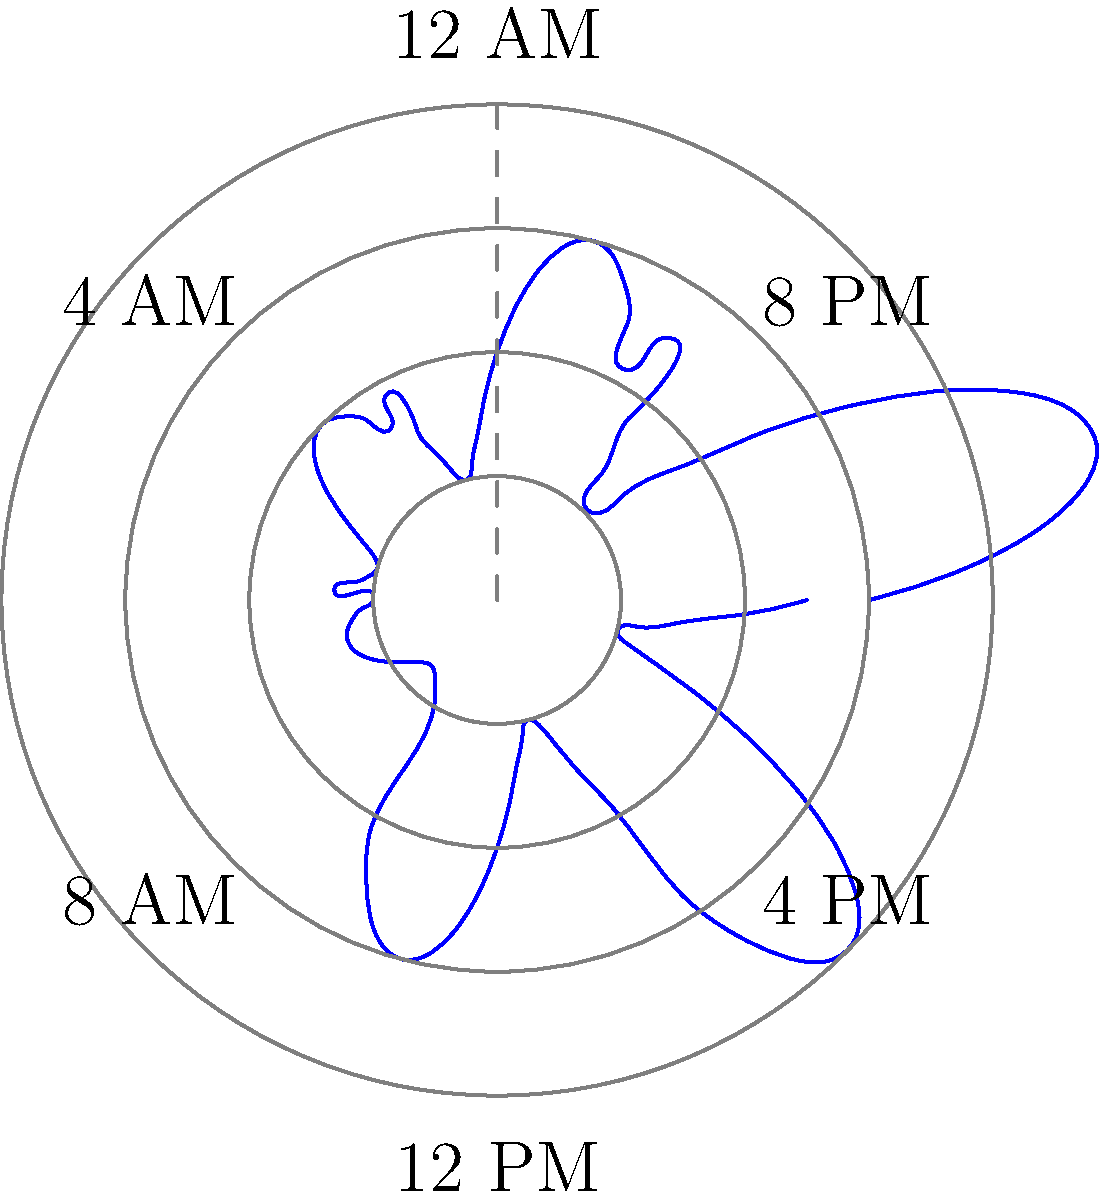Based on the polar rose diagram representing viewer engagement patterns over a 24-hour broadcast cycle, during which time period does the news broadcast experience its highest viewer engagement? To determine the time period with the highest viewer engagement, we need to analyze the polar rose diagram:

1. The diagram represents a 24-hour cycle, with each "petal" covering a 4-hour period.
2. The distance from the center represents the level of viewer engagement.
3. We need to identify the petal that extends the furthest from the center.

Examining the diagram:
- 12 AM to 4 AM: Moderate engagement
- 4 AM to 8 AM: High engagement, second largest petal
- 8 AM to 12 PM: Low engagement
- 12 PM to 4 PM: Lowest engagement
- 4 PM to 8 PM: Moderate engagement, similar to 12 AM - 4 AM
- 8 PM to 12 AM: Highest engagement, largest petal

The petal representing the time period from 8 PM to 12 AM (midnight) extends the furthest from the center, indicating the highest viewer engagement during this time.
Answer: 8 PM to 12 AM 